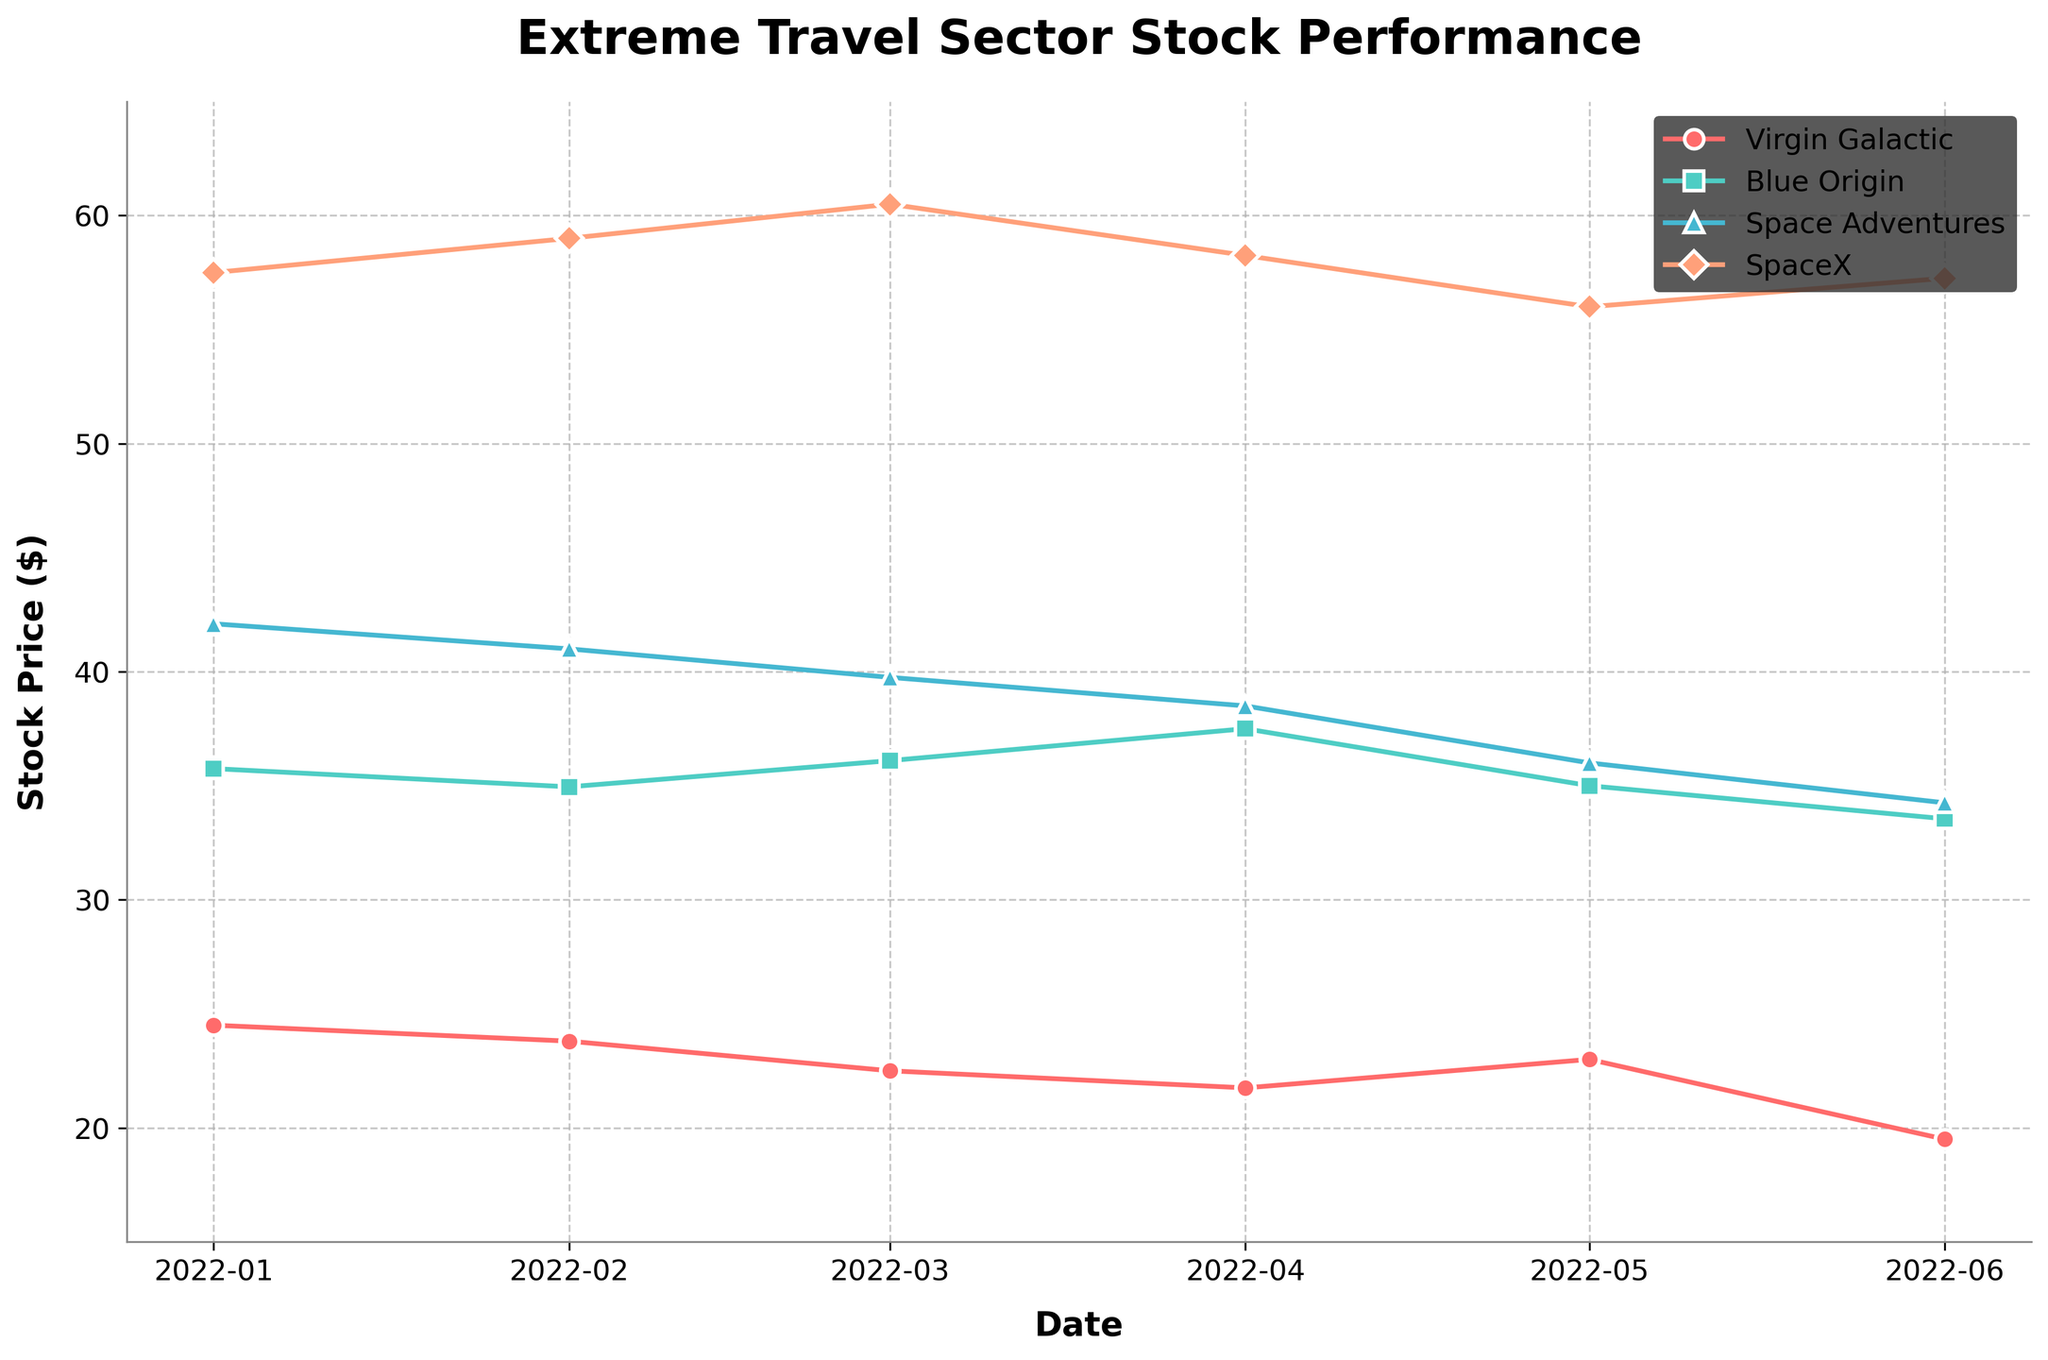What is the title of the plot? The title of the plot is displayed at the top center of the figure.
Answer: Extreme Travel Sector Stock Performance How many companies’ stock performances are shown in the plot? By examining the legend, which lists all the companies, we can count the total number of companies.
Answer: 4 Which company had the highest stock price in January 2022? By looking at the data points for January 2022, the highest value can be identified. Based on the plot, SpaceX had the highest price.
Answer: SpaceX What is the overall trend of Virgin Galactic's stock price from January 2022 to June 2022? Observing the line for Virgin Galactic, we can see that its stock price starts at a higher value and generally decreases over time, with a slight oscillation.
Answer: Decreasing Compare the performance of Blue Origin and Space Adventures in June 2022. Which had a higher stock price? By locating the data points for June 2022 for both companies, we can directly compare their values. Blue Origin had a higher price than Space Adventures.
Answer: Blue Origin Which company shows the most significant drop in stock price from January to June 2022? By calculating the difference in stock prices for each company between January and June 2022 and comparing these differences, Space Adventures shows the most significant drop.
Answer: Space Adventures What is the approximate average stock price of SpaceX from January 2022 to June 2022? Sum the stock prices of SpaceX for each month and then divide by the number of months (6). (57.50 + 59.00 + 60.50 + 58.25 + 56.00 + 57.25) / 6 = 348.5 / 6 = 58.08
Answer: 58.08 Which month did SpaceX experience a decline but still maintained the highest stock price compared to the other companies? By observing the plot, SpaceX experienced a decline in May 2022. Despite this decline, SpaceX still had the highest stock price compared to the other companies in that month.
Answer: May 2022 Does any company show an increasing trend in stock prices from January to June 2022? Observing the trends for each company, no company shows a consistently increasing trend in their stock prices throughout the specified period.
Answer: No What is the color and marker shape for Blue Origin in the plot? By referring to the plot legend, we can see the specific color and marker shape used for Blue Origin. Blue Origin is represented with turquoise color and a square marker.
Answer: Turquoise, square 